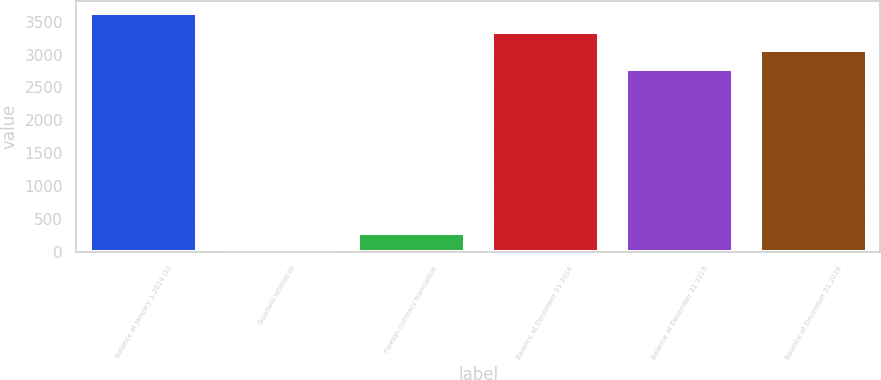Convert chart to OTSL. <chart><loc_0><loc_0><loc_500><loc_500><bar_chart><fcel>Balance at January 1 2014 (1)<fcel>Goodwill related to<fcel>Foreign currency translation<fcel>Balance at December 31 2014<fcel>Balance at December 31 2015<fcel>Balance at December 31 2016<nl><fcel>3626<fcel>12<fcel>292<fcel>3346<fcel>2786<fcel>3066<nl></chart> 